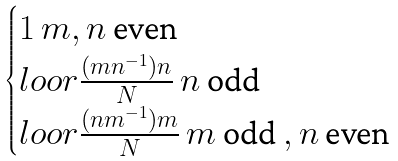<formula> <loc_0><loc_0><loc_500><loc_500>\begin{cases} 1 \, m , n \text { even } \\ l o o r { \frac { ( m n ^ { - 1 } ) n } { N } } \, n \text { odd } \\ l o o r { \frac { ( n m ^ { - 1 } ) m } { N } } \, m \text { odd } , n \text { even } \end{cases}</formula> 